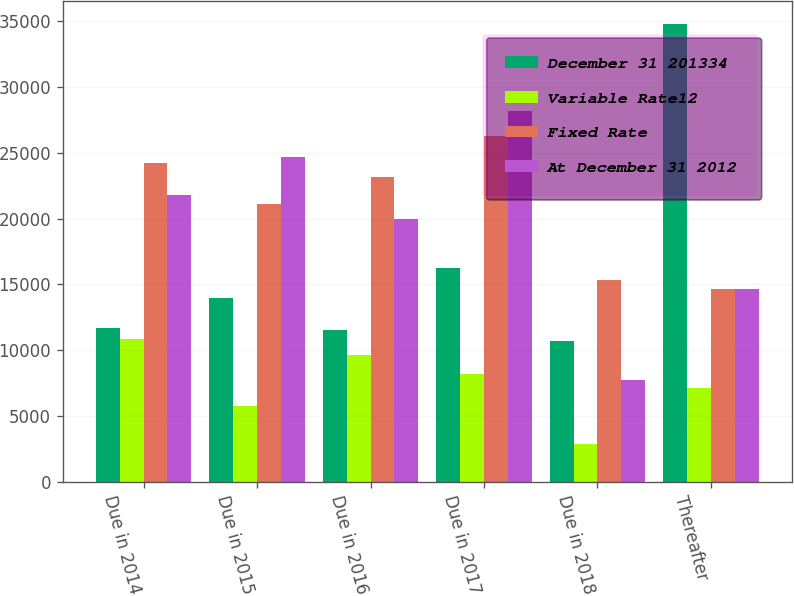<chart> <loc_0><loc_0><loc_500><loc_500><stacked_bar_chart><ecel><fcel>Due in 2014<fcel>Due in 2015<fcel>Due in 2016<fcel>Due in 2017<fcel>Due in 2018<fcel>Thereafter<nl><fcel>December 31 201334<fcel>11665<fcel>13962<fcel>11521<fcel>16227<fcel>10689<fcel>34748<nl><fcel>Variable Rate12<fcel>10830<fcel>5760<fcel>9621<fcel>8231<fcel>2886<fcel>7165<nl><fcel>Fixed Rate<fcel>24193<fcel>21090<fcel>23144<fcel>26295<fcel>15308<fcel>14635<nl><fcel>At December 31 2012<fcel>21751<fcel>24653<fcel>19984<fcel>28137<fcel>7733<fcel>14635<nl></chart> 